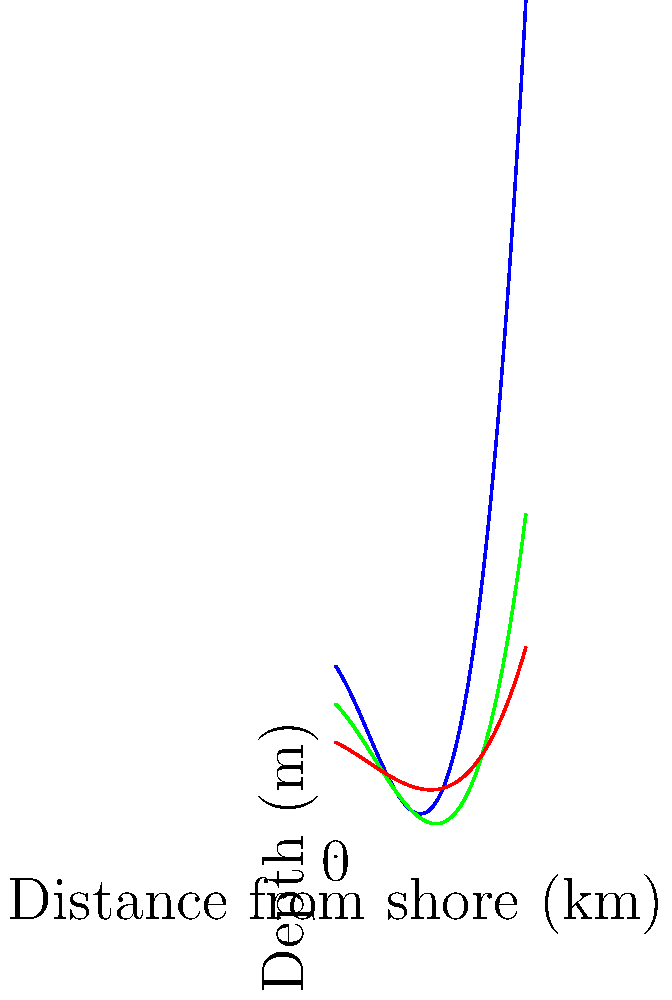The diagram shows a cross-section of ocean layers along Australia's eastern coast. How does the thermocline (green line) change as you move further from the shore, and what might this indicate about the marine ecosystem? To answer this question, let's analyze the diagram step-by-step:

1. Observe the green line representing the thermocline:
   - It starts relatively close to the surface near the shore.
   - As we move away from the shore, it dips down and then gradually rises again.

2. Understanding the thermocline:
   - The thermocline is a layer where temperature changes rapidly with depth.
   - It separates the warmer surface waters from the cooler deep waters.

3. Coastal upwelling:
   - Note the arrow indicating coastal upwelling near the shore.
   - Upwelling brings nutrient-rich deep water to the surface.

4. Implications for the marine ecosystem:
   - Near the shore: The thermocline is shallow due to upwelling. This means nutrient-rich water is closer to the surface, supporting high productivity.
   - Mid-distance: The thermocline dips, creating a larger warm surface layer. This might indicate an area of lower productivity.
   - Further offshore: The thermocline rises again, possibly due to oceanic processes like eddies or currents.

5. Overall ecosystem impact:
   - The changing depth of the thermocline creates diverse habitats.
   - Areas with a shallower thermocline (near shore and far offshore) likely have higher productivity and biodiversity.
   - The mid-distance area might have different species adapted to warmer, potentially less nutrient-rich waters.
Answer: The thermocline dips then rises, indicating varying productivity zones and diverse habitats along the coast. 